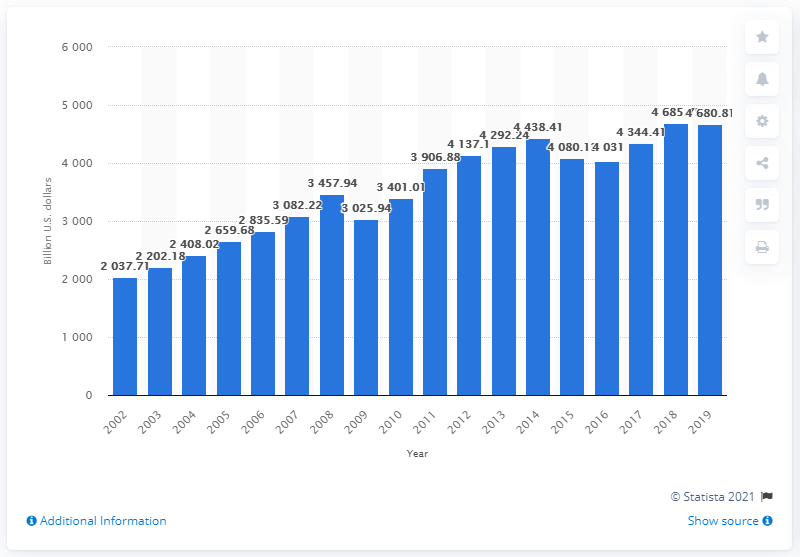List a handful of essential elements in this visual. In 2019, the total sales of nondurable goods by U.S. merchant wholesalers was 4,680.81. 